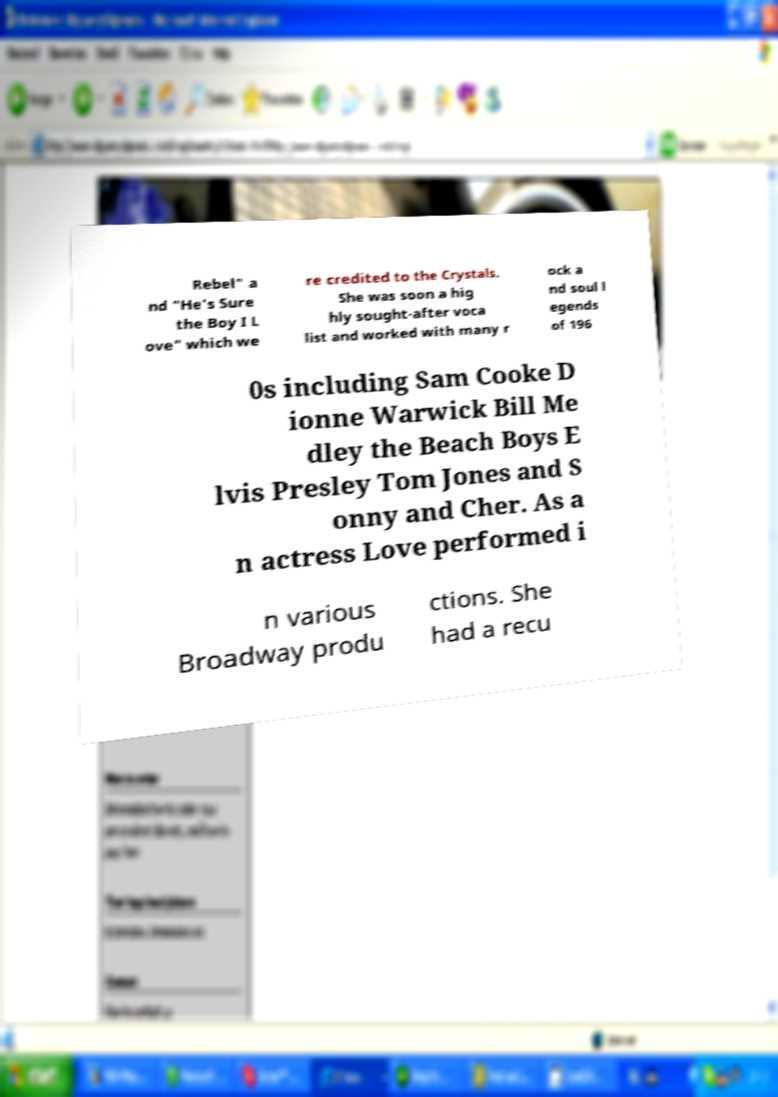Could you extract and type out the text from this image? Rebel" a nd "He's Sure the Boy I L ove" which we re credited to the Crystals. She was soon a hig hly sought-after voca list and worked with many r ock a nd soul l egends of 196 0s including Sam Cooke D ionne Warwick Bill Me dley the Beach Boys E lvis Presley Tom Jones and S onny and Cher. As a n actress Love performed i n various Broadway produ ctions. She had a recu 